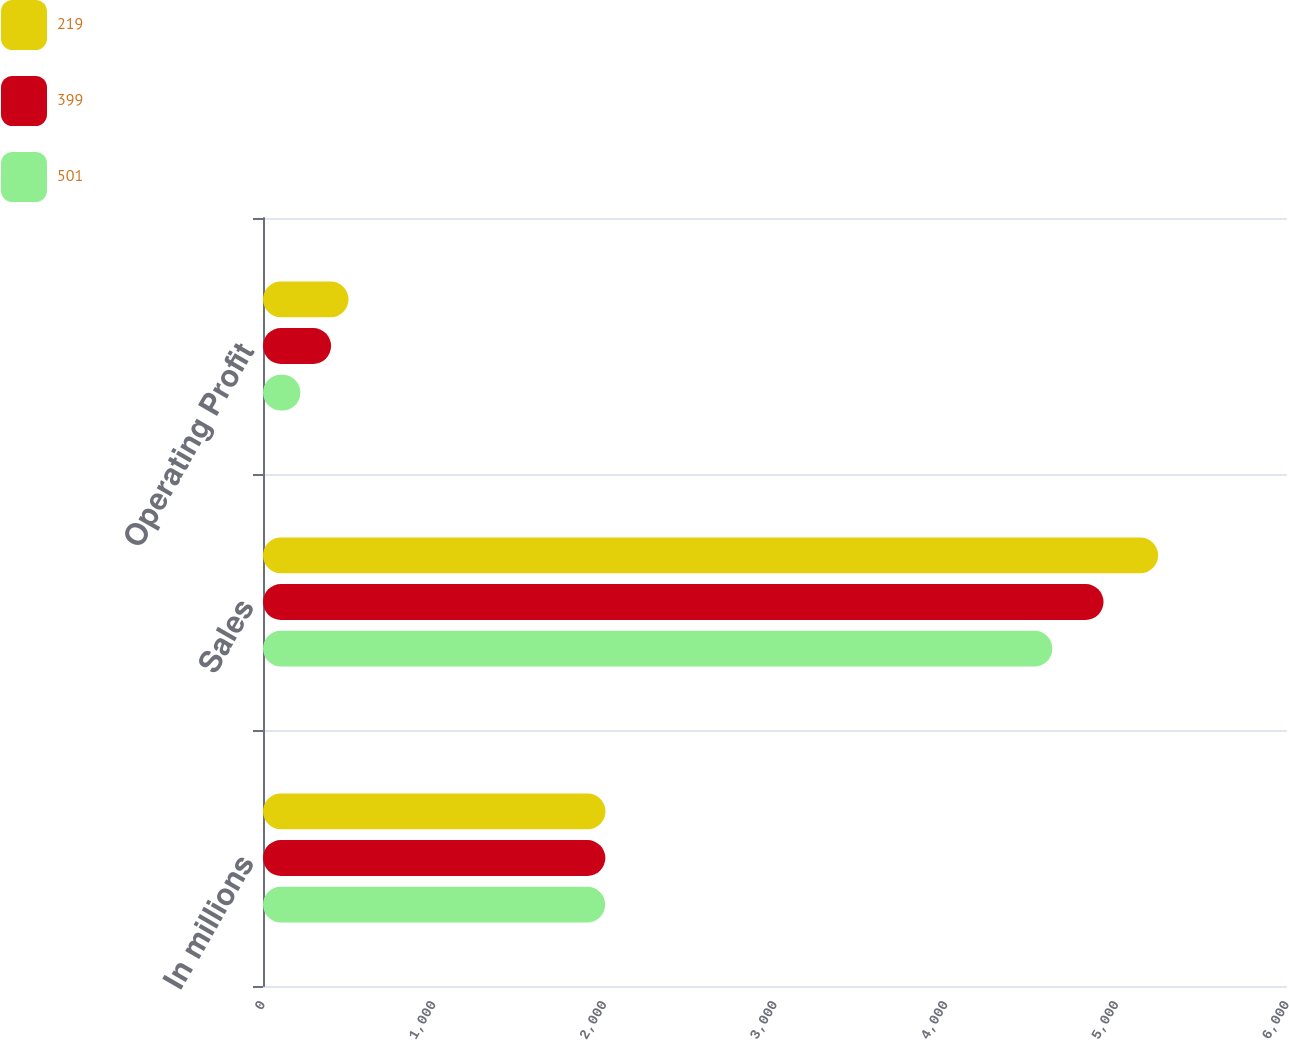Convert chart to OTSL. <chart><loc_0><loc_0><loc_500><loc_500><stacked_bar_chart><ecel><fcel>In millions<fcel>Sales<fcel>Operating Profit<nl><fcel>219<fcel>2007<fcel>5245<fcel>501<nl><fcel>399<fcel>2006<fcel>4925<fcel>399<nl><fcel>501<fcel>2005<fcel>4625<fcel>219<nl></chart> 